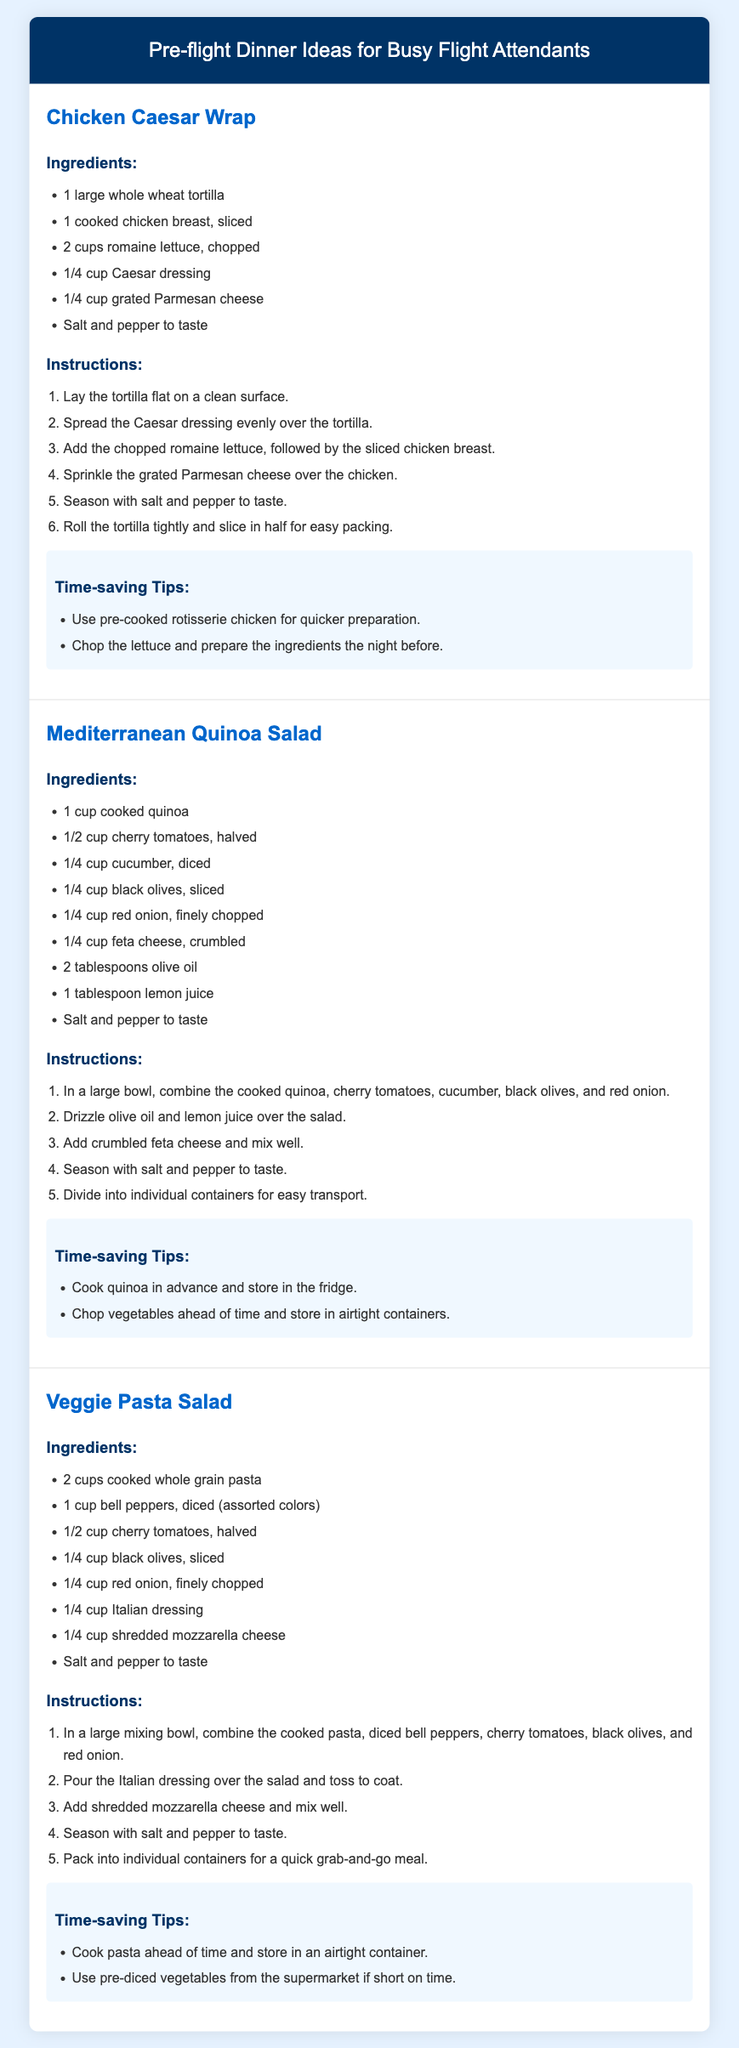What is the first recipe listed? The first recipe in the document is "Chicken Caesar Wrap."
Answer: Chicken Caesar Wrap How many ingredients are needed for the Mediterranean Quinoa Salad? The Mediterranean Quinoa Salad recipe lists a total of 9 ingredients.
Answer: 9 What is a time-saving tip for the Chicken Caesar Wrap? One of the time-saving tips for the Chicken Caesar Wrap is to use pre-cooked rotisserie chicken for quicker preparation.
Answer: Use pre-cooked rotisserie chicken What is the primary protein source in the Veggie Pasta Salad? The primary protein source in the Veggie Pasta Salad is shredded mozzarella cheese.
Answer: Shredded mozzarella cheese How many steps are there in the instructions for the Mediterranean Quinoa Salad? There are 5 steps outlined in the instructions for the Mediterranean Quinoa Salad.
Answer: 5 steps What ingredient is used for dressing in the Veggie Pasta Salad? The Veggie Pasta Salad uses Italian dressing as the dressing ingredient.
Answer: Italian dressing What is the main carbohydrate source in the Chicken Caesar Wrap? The main carbohydrate source in the Chicken Caesar Wrap is the large whole wheat tortilla.
Answer: Whole wheat tortilla What is the color of the header in the document? The header color in the document is white.
Answer: White 